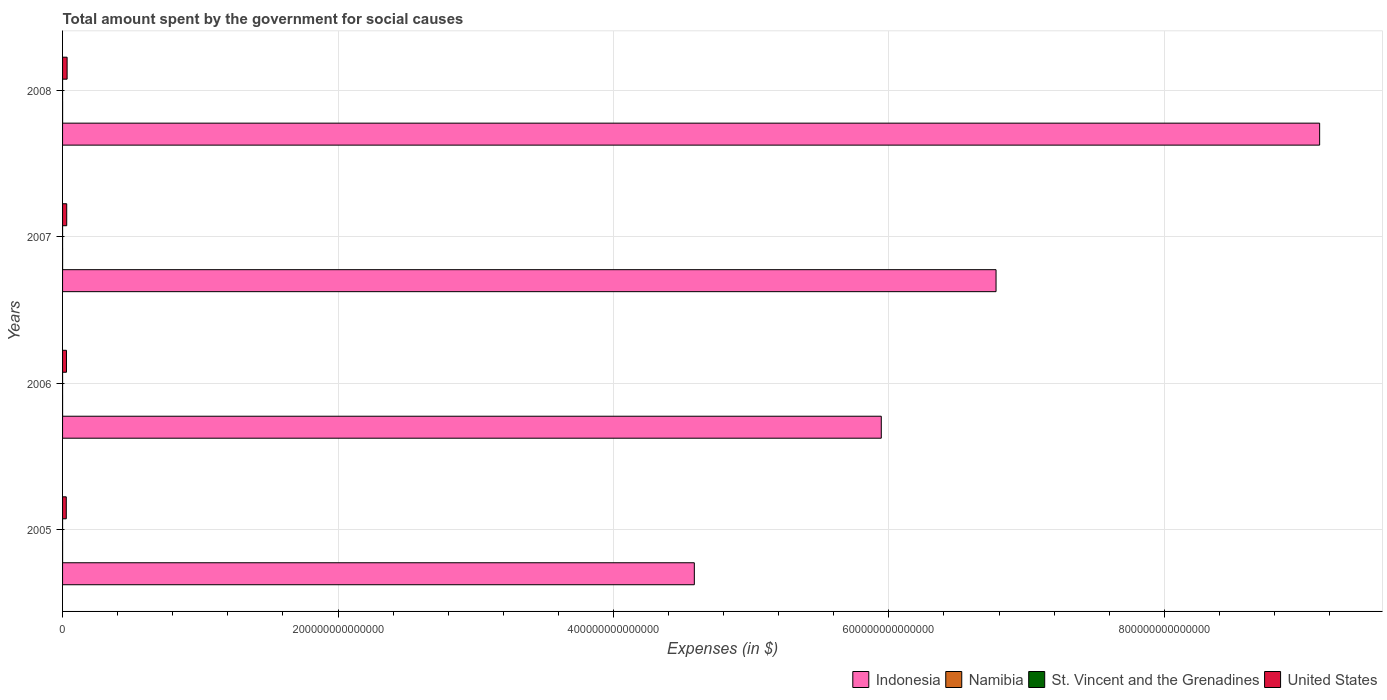How many different coloured bars are there?
Offer a very short reply. 4. How many groups of bars are there?
Make the answer very short. 4. Are the number of bars per tick equal to the number of legend labels?
Your answer should be compact. Yes. How many bars are there on the 1st tick from the top?
Your answer should be compact. 4. How many bars are there on the 4th tick from the bottom?
Provide a short and direct response. 4. In how many cases, is the number of bars for a given year not equal to the number of legend labels?
Offer a terse response. 0. What is the amount spent for social causes by the government in Namibia in 2005?
Offer a very short reply. 1.18e+1. Across all years, what is the maximum amount spent for social causes by the government in Indonesia?
Your answer should be very brief. 9.13e+14. Across all years, what is the minimum amount spent for social causes by the government in United States?
Provide a short and direct response. 2.70e+12. What is the total amount spent for social causes by the government in Namibia in the graph?
Provide a short and direct response. 5.79e+1. What is the difference between the amount spent for social causes by the government in Namibia in 2006 and that in 2007?
Your answer should be very brief. -1.83e+09. What is the difference between the amount spent for social causes by the government in United States in 2008 and the amount spent for social causes by the government in St. Vincent and the Grenadines in 2007?
Provide a short and direct response. 3.29e+12. What is the average amount spent for social causes by the government in Indonesia per year?
Offer a very short reply. 6.61e+14. In the year 2006, what is the difference between the amount spent for social causes by the government in United States and amount spent for social causes by the government in Namibia?
Offer a terse response. 2.83e+12. What is the ratio of the amount spent for social causes by the government in St. Vincent and the Grenadines in 2007 to that in 2008?
Give a very brief answer. 0.88. What is the difference between the highest and the second highest amount spent for social causes by the government in Indonesia?
Your response must be concise. 2.35e+14. What is the difference between the highest and the lowest amount spent for social causes by the government in Namibia?
Your answer should be very brief. 6.18e+09. In how many years, is the amount spent for social causes by the government in St. Vincent and the Grenadines greater than the average amount spent for social causes by the government in St. Vincent and the Grenadines taken over all years?
Your response must be concise. 2. Is the sum of the amount spent for social causes by the government in Indonesia in 2006 and 2007 greater than the maximum amount spent for social causes by the government in Namibia across all years?
Keep it short and to the point. Yes. Is it the case that in every year, the sum of the amount spent for social causes by the government in Namibia and amount spent for social causes by the government in United States is greater than the sum of amount spent for social causes by the government in Indonesia and amount spent for social causes by the government in St. Vincent and the Grenadines?
Provide a short and direct response. Yes. What does the 3rd bar from the top in 2005 represents?
Provide a short and direct response. Namibia. What does the 3rd bar from the bottom in 2007 represents?
Your response must be concise. St. Vincent and the Grenadines. How many bars are there?
Make the answer very short. 16. How many years are there in the graph?
Your response must be concise. 4. What is the difference between two consecutive major ticks on the X-axis?
Provide a short and direct response. 2.00e+14. Does the graph contain any zero values?
Keep it short and to the point. No. Does the graph contain grids?
Your answer should be compact. Yes. How are the legend labels stacked?
Your answer should be very brief. Horizontal. What is the title of the graph?
Your response must be concise. Total amount spent by the government for social causes. What is the label or title of the X-axis?
Offer a very short reply. Expenses (in $). What is the label or title of the Y-axis?
Your answer should be compact. Years. What is the Expenses (in $) in Indonesia in 2005?
Offer a terse response. 4.59e+14. What is the Expenses (in $) of Namibia in 2005?
Your answer should be very brief. 1.18e+1. What is the Expenses (in $) in St. Vincent and the Grenadines in 2005?
Your response must be concise. 3.27e+08. What is the Expenses (in $) in United States in 2005?
Ensure brevity in your answer.  2.70e+12. What is the Expenses (in $) in Indonesia in 2006?
Your answer should be compact. 5.94e+14. What is the Expenses (in $) in Namibia in 2006?
Your answer should be very brief. 1.31e+1. What is the Expenses (in $) in St. Vincent and the Grenadines in 2006?
Ensure brevity in your answer.  3.56e+08. What is the Expenses (in $) in United States in 2006?
Your answer should be very brief. 2.84e+12. What is the Expenses (in $) in Indonesia in 2007?
Offer a terse response. 6.78e+14. What is the Expenses (in $) of Namibia in 2007?
Provide a succinct answer. 1.49e+1. What is the Expenses (in $) of St. Vincent and the Grenadines in 2007?
Keep it short and to the point. 3.79e+08. What is the Expenses (in $) in United States in 2007?
Provide a succinct answer. 3.01e+12. What is the Expenses (in $) in Indonesia in 2008?
Offer a terse response. 9.13e+14. What is the Expenses (in $) in Namibia in 2008?
Offer a terse response. 1.80e+1. What is the Expenses (in $) of St. Vincent and the Grenadines in 2008?
Give a very brief answer. 4.31e+08. What is the Expenses (in $) of United States in 2008?
Keep it short and to the point. 3.30e+12. Across all years, what is the maximum Expenses (in $) of Indonesia?
Ensure brevity in your answer.  9.13e+14. Across all years, what is the maximum Expenses (in $) in Namibia?
Give a very brief answer. 1.80e+1. Across all years, what is the maximum Expenses (in $) of St. Vincent and the Grenadines?
Provide a succinct answer. 4.31e+08. Across all years, what is the maximum Expenses (in $) of United States?
Your answer should be very brief. 3.30e+12. Across all years, what is the minimum Expenses (in $) of Indonesia?
Offer a very short reply. 4.59e+14. Across all years, what is the minimum Expenses (in $) in Namibia?
Keep it short and to the point. 1.18e+1. Across all years, what is the minimum Expenses (in $) of St. Vincent and the Grenadines?
Provide a short and direct response. 3.27e+08. Across all years, what is the minimum Expenses (in $) of United States?
Provide a succinct answer. 2.70e+12. What is the total Expenses (in $) of Indonesia in the graph?
Ensure brevity in your answer.  2.64e+15. What is the total Expenses (in $) in Namibia in the graph?
Ensure brevity in your answer.  5.79e+1. What is the total Expenses (in $) of St. Vincent and the Grenadines in the graph?
Your answer should be very brief. 1.49e+09. What is the total Expenses (in $) in United States in the graph?
Make the answer very short. 1.18e+13. What is the difference between the Expenses (in $) of Indonesia in 2005 and that in 2006?
Provide a succinct answer. -1.36e+14. What is the difference between the Expenses (in $) in Namibia in 2005 and that in 2006?
Offer a terse response. -1.27e+09. What is the difference between the Expenses (in $) of St. Vincent and the Grenadines in 2005 and that in 2006?
Ensure brevity in your answer.  -2.93e+07. What is the difference between the Expenses (in $) of United States in 2005 and that in 2006?
Provide a short and direct response. -1.41e+11. What is the difference between the Expenses (in $) of Indonesia in 2005 and that in 2007?
Your response must be concise. -2.19e+14. What is the difference between the Expenses (in $) in Namibia in 2005 and that in 2007?
Keep it short and to the point. -3.11e+09. What is the difference between the Expenses (in $) of St. Vincent and the Grenadines in 2005 and that in 2007?
Your answer should be very brief. -5.17e+07. What is the difference between the Expenses (in $) of United States in 2005 and that in 2007?
Provide a succinct answer. -3.15e+11. What is the difference between the Expenses (in $) of Indonesia in 2005 and that in 2008?
Keep it short and to the point. -4.54e+14. What is the difference between the Expenses (in $) of Namibia in 2005 and that in 2008?
Offer a terse response. -6.18e+09. What is the difference between the Expenses (in $) of St. Vincent and the Grenadines in 2005 and that in 2008?
Your response must be concise. -1.04e+08. What is the difference between the Expenses (in $) of United States in 2005 and that in 2008?
Offer a very short reply. -5.97e+11. What is the difference between the Expenses (in $) in Indonesia in 2006 and that in 2007?
Your response must be concise. -8.33e+13. What is the difference between the Expenses (in $) in Namibia in 2006 and that in 2007?
Your answer should be compact. -1.83e+09. What is the difference between the Expenses (in $) in St. Vincent and the Grenadines in 2006 and that in 2007?
Provide a short and direct response. -2.24e+07. What is the difference between the Expenses (in $) of United States in 2006 and that in 2007?
Make the answer very short. -1.74e+11. What is the difference between the Expenses (in $) of Indonesia in 2006 and that in 2008?
Your response must be concise. -3.18e+14. What is the difference between the Expenses (in $) in Namibia in 2006 and that in 2008?
Offer a terse response. -4.91e+09. What is the difference between the Expenses (in $) in St. Vincent and the Grenadines in 2006 and that in 2008?
Make the answer very short. -7.44e+07. What is the difference between the Expenses (in $) in United States in 2006 and that in 2008?
Give a very brief answer. -4.56e+11. What is the difference between the Expenses (in $) of Indonesia in 2007 and that in 2008?
Ensure brevity in your answer.  -2.35e+14. What is the difference between the Expenses (in $) of Namibia in 2007 and that in 2008?
Ensure brevity in your answer.  -3.08e+09. What is the difference between the Expenses (in $) in St. Vincent and the Grenadines in 2007 and that in 2008?
Your answer should be very brief. -5.20e+07. What is the difference between the Expenses (in $) of United States in 2007 and that in 2008?
Make the answer very short. -2.81e+11. What is the difference between the Expenses (in $) of Indonesia in 2005 and the Expenses (in $) of Namibia in 2006?
Provide a succinct answer. 4.59e+14. What is the difference between the Expenses (in $) in Indonesia in 2005 and the Expenses (in $) in St. Vincent and the Grenadines in 2006?
Your response must be concise. 4.59e+14. What is the difference between the Expenses (in $) of Indonesia in 2005 and the Expenses (in $) of United States in 2006?
Keep it short and to the point. 4.56e+14. What is the difference between the Expenses (in $) in Namibia in 2005 and the Expenses (in $) in St. Vincent and the Grenadines in 2006?
Offer a very short reply. 1.15e+1. What is the difference between the Expenses (in $) of Namibia in 2005 and the Expenses (in $) of United States in 2006?
Your answer should be compact. -2.83e+12. What is the difference between the Expenses (in $) in St. Vincent and the Grenadines in 2005 and the Expenses (in $) in United States in 2006?
Keep it short and to the point. -2.84e+12. What is the difference between the Expenses (in $) in Indonesia in 2005 and the Expenses (in $) in Namibia in 2007?
Offer a terse response. 4.59e+14. What is the difference between the Expenses (in $) of Indonesia in 2005 and the Expenses (in $) of St. Vincent and the Grenadines in 2007?
Offer a very short reply. 4.59e+14. What is the difference between the Expenses (in $) in Indonesia in 2005 and the Expenses (in $) in United States in 2007?
Ensure brevity in your answer.  4.56e+14. What is the difference between the Expenses (in $) of Namibia in 2005 and the Expenses (in $) of St. Vincent and the Grenadines in 2007?
Offer a very short reply. 1.15e+1. What is the difference between the Expenses (in $) of Namibia in 2005 and the Expenses (in $) of United States in 2007?
Your answer should be compact. -3.00e+12. What is the difference between the Expenses (in $) in St. Vincent and the Grenadines in 2005 and the Expenses (in $) in United States in 2007?
Make the answer very short. -3.01e+12. What is the difference between the Expenses (in $) in Indonesia in 2005 and the Expenses (in $) in Namibia in 2008?
Provide a succinct answer. 4.59e+14. What is the difference between the Expenses (in $) of Indonesia in 2005 and the Expenses (in $) of St. Vincent and the Grenadines in 2008?
Provide a succinct answer. 4.59e+14. What is the difference between the Expenses (in $) in Indonesia in 2005 and the Expenses (in $) in United States in 2008?
Keep it short and to the point. 4.55e+14. What is the difference between the Expenses (in $) of Namibia in 2005 and the Expenses (in $) of St. Vincent and the Grenadines in 2008?
Give a very brief answer. 1.14e+1. What is the difference between the Expenses (in $) of Namibia in 2005 and the Expenses (in $) of United States in 2008?
Your response must be concise. -3.28e+12. What is the difference between the Expenses (in $) in St. Vincent and the Grenadines in 2005 and the Expenses (in $) in United States in 2008?
Give a very brief answer. -3.29e+12. What is the difference between the Expenses (in $) of Indonesia in 2006 and the Expenses (in $) of Namibia in 2007?
Give a very brief answer. 5.94e+14. What is the difference between the Expenses (in $) of Indonesia in 2006 and the Expenses (in $) of St. Vincent and the Grenadines in 2007?
Offer a terse response. 5.94e+14. What is the difference between the Expenses (in $) of Indonesia in 2006 and the Expenses (in $) of United States in 2007?
Make the answer very short. 5.91e+14. What is the difference between the Expenses (in $) of Namibia in 2006 and the Expenses (in $) of St. Vincent and the Grenadines in 2007?
Provide a succinct answer. 1.27e+1. What is the difference between the Expenses (in $) in Namibia in 2006 and the Expenses (in $) in United States in 2007?
Your answer should be compact. -3.00e+12. What is the difference between the Expenses (in $) of St. Vincent and the Grenadines in 2006 and the Expenses (in $) of United States in 2007?
Give a very brief answer. -3.01e+12. What is the difference between the Expenses (in $) of Indonesia in 2006 and the Expenses (in $) of Namibia in 2008?
Provide a short and direct response. 5.94e+14. What is the difference between the Expenses (in $) of Indonesia in 2006 and the Expenses (in $) of St. Vincent and the Grenadines in 2008?
Your answer should be very brief. 5.94e+14. What is the difference between the Expenses (in $) in Indonesia in 2006 and the Expenses (in $) in United States in 2008?
Provide a short and direct response. 5.91e+14. What is the difference between the Expenses (in $) in Namibia in 2006 and the Expenses (in $) in St. Vincent and the Grenadines in 2008?
Your response must be concise. 1.27e+1. What is the difference between the Expenses (in $) in Namibia in 2006 and the Expenses (in $) in United States in 2008?
Your answer should be compact. -3.28e+12. What is the difference between the Expenses (in $) of St. Vincent and the Grenadines in 2006 and the Expenses (in $) of United States in 2008?
Your answer should be compact. -3.29e+12. What is the difference between the Expenses (in $) of Indonesia in 2007 and the Expenses (in $) of Namibia in 2008?
Offer a very short reply. 6.78e+14. What is the difference between the Expenses (in $) of Indonesia in 2007 and the Expenses (in $) of St. Vincent and the Grenadines in 2008?
Keep it short and to the point. 6.78e+14. What is the difference between the Expenses (in $) of Indonesia in 2007 and the Expenses (in $) of United States in 2008?
Keep it short and to the point. 6.75e+14. What is the difference between the Expenses (in $) of Namibia in 2007 and the Expenses (in $) of St. Vincent and the Grenadines in 2008?
Provide a short and direct response. 1.45e+1. What is the difference between the Expenses (in $) in Namibia in 2007 and the Expenses (in $) in United States in 2008?
Ensure brevity in your answer.  -3.28e+12. What is the difference between the Expenses (in $) of St. Vincent and the Grenadines in 2007 and the Expenses (in $) of United States in 2008?
Your response must be concise. -3.29e+12. What is the average Expenses (in $) in Indonesia per year?
Your answer should be very brief. 6.61e+14. What is the average Expenses (in $) of Namibia per year?
Keep it short and to the point. 1.45e+1. What is the average Expenses (in $) of St. Vincent and the Grenadines per year?
Offer a very short reply. 3.73e+08. What is the average Expenses (in $) of United States per year?
Offer a terse response. 2.96e+12. In the year 2005, what is the difference between the Expenses (in $) of Indonesia and Expenses (in $) of Namibia?
Your answer should be very brief. 4.59e+14. In the year 2005, what is the difference between the Expenses (in $) in Indonesia and Expenses (in $) in St. Vincent and the Grenadines?
Make the answer very short. 4.59e+14. In the year 2005, what is the difference between the Expenses (in $) of Indonesia and Expenses (in $) of United States?
Offer a very short reply. 4.56e+14. In the year 2005, what is the difference between the Expenses (in $) in Namibia and Expenses (in $) in St. Vincent and the Grenadines?
Ensure brevity in your answer.  1.15e+1. In the year 2005, what is the difference between the Expenses (in $) in Namibia and Expenses (in $) in United States?
Your answer should be very brief. -2.69e+12. In the year 2005, what is the difference between the Expenses (in $) in St. Vincent and the Grenadines and Expenses (in $) in United States?
Your answer should be compact. -2.70e+12. In the year 2006, what is the difference between the Expenses (in $) of Indonesia and Expenses (in $) of Namibia?
Offer a very short reply. 5.94e+14. In the year 2006, what is the difference between the Expenses (in $) of Indonesia and Expenses (in $) of St. Vincent and the Grenadines?
Provide a succinct answer. 5.94e+14. In the year 2006, what is the difference between the Expenses (in $) in Indonesia and Expenses (in $) in United States?
Your response must be concise. 5.92e+14. In the year 2006, what is the difference between the Expenses (in $) in Namibia and Expenses (in $) in St. Vincent and the Grenadines?
Make the answer very short. 1.28e+1. In the year 2006, what is the difference between the Expenses (in $) in Namibia and Expenses (in $) in United States?
Ensure brevity in your answer.  -2.83e+12. In the year 2006, what is the difference between the Expenses (in $) of St. Vincent and the Grenadines and Expenses (in $) of United States?
Provide a short and direct response. -2.84e+12. In the year 2007, what is the difference between the Expenses (in $) of Indonesia and Expenses (in $) of Namibia?
Ensure brevity in your answer.  6.78e+14. In the year 2007, what is the difference between the Expenses (in $) of Indonesia and Expenses (in $) of St. Vincent and the Grenadines?
Offer a terse response. 6.78e+14. In the year 2007, what is the difference between the Expenses (in $) in Indonesia and Expenses (in $) in United States?
Ensure brevity in your answer.  6.75e+14. In the year 2007, what is the difference between the Expenses (in $) in Namibia and Expenses (in $) in St. Vincent and the Grenadines?
Your answer should be very brief. 1.46e+1. In the year 2007, what is the difference between the Expenses (in $) in Namibia and Expenses (in $) in United States?
Your answer should be compact. -3.00e+12. In the year 2007, what is the difference between the Expenses (in $) of St. Vincent and the Grenadines and Expenses (in $) of United States?
Your answer should be compact. -3.01e+12. In the year 2008, what is the difference between the Expenses (in $) in Indonesia and Expenses (in $) in Namibia?
Give a very brief answer. 9.13e+14. In the year 2008, what is the difference between the Expenses (in $) of Indonesia and Expenses (in $) of St. Vincent and the Grenadines?
Your response must be concise. 9.13e+14. In the year 2008, what is the difference between the Expenses (in $) of Indonesia and Expenses (in $) of United States?
Provide a short and direct response. 9.09e+14. In the year 2008, what is the difference between the Expenses (in $) of Namibia and Expenses (in $) of St. Vincent and the Grenadines?
Provide a succinct answer. 1.76e+1. In the year 2008, what is the difference between the Expenses (in $) in Namibia and Expenses (in $) in United States?
Provide a short and direct response. -3.28e+12. In the year 2008, what is the difference between the Expenses (in $) in St. Vincent and the Grenadines and Expenses (in $) in United States?
Your answer should be very brief. -3.29e+12. What is the ratio of the Expenses (in $) of Indonesia in 2005 to that in 2006?
Provide a short and direct response. 0.77. What is the ratio of the Expenses (in $) of Namibia in 2005 to that in 2006?
Ensure brevity in your answer.  0.9. What is the ratio of the Expenses (in $) of St. Vincent and the Grenadines in 2005 to that in 2006?
Offer a terse response. 0.92. What is the ratio of the Expenses (in $) of United States in 2005 to that in 2006?
Provide a succinct answer. 0.95. What is the ratio of the Expenses (in $) in Indonesia in 2005 to that in 2007?
Your answer should be very brief. 0.68. What is the ratio of the Expenses (in $) in Namibia in 2005 to that in 2007?
Keep it short and to the point. 0.79. What is the ratio of the Expenses (in $) in St. Vincent and the Grenadines in 2005 to that in 2007?
Ensure brevity in your answer.  0.86. What is the ratio of the Expenses (in $) in United States in 2005 to that in 2007?
Offer a terse response. 0.9. What is the ratio of the Expenses (in $) in Indonesia in 2005 to that in 2008?
Your answer should be compact. 0.5. What is the ratio of the Expenses (in $) of Namibia in 2005 to that in 2008?
Give a very brief answer. 0.66. What is the ratio of the Expenses (in $) in St. Vincent and the Grenadines in 2005 to that in 2008?
Your answer should be compact. 0.76. What is the ratio of the Expenses (in $) of United States in 2005 to that in 2008?
Give a very brief answer. 0.82. What is the ratio of the Expenses (in $) of Indonesia in 2006 to that in 2007?
Offer a terse response. 0.88. What is the ratio of the Expenses (in $) of Namibia in 2006 to that in 2007?
Keep it short and to the point. 0.88. What is the ratio of the Expenses (in $) in St. Vincent and the Grenadines in 2006 to that in 2007?
Give a very brief answer. 0.94. What is the ratio of the Expenses (in $) in United States in 2006 to that in 2007?
Offer a very short reply. 0.94. What is the ratio of the Expenses (in $) of Indonesia in 2006 to that in 2008?
Your response must be concise. 0.65. What is the ratio of the Expenses (in $) of Namibia in 2006 to that in 2008?
Make the answer very short. 0.73. What is the ratio of the Expenses (in $) of St. Vincent and the Grenadines in 2006 to that in 2008?
Make the answer very short. 0.83. What is the ratio of the Expenses (in $) of United States in 2006 to that in 2008?
Keep it short and to the point. 0.86. What is the ratio of the Expenses (in $) of Indonesia in 2007 to that in 2008?
Provide a succinct answer. 0.74. What is the ratio of the Expenses (in $) in Namibia in 2007 to that in 2008?
Provide a succinct answer. 0.83. What is the ratio of the Expenses (in $) in St. Vincent and the Grenadines in 2007 to that in 2008?
Provide a short and direct response. 0.88. What is the ratio of the Expenses (in $) of United States in 2007 to that in 2008?
Your response must be concise. 0.91. What is the difference between the highest and the second highest Expenses (in $) of Indonesia?
Offer a very short reply. 2.35e+14. What is the difference between the highest and the second highest Expenses (in $) of Namibia?
Offer a terse response. 3.08e+09. What is the difference between the highest and the second highest Expenses (in $) of St. Vincent and the Grenadines?
Offer a terse response. 5.20e+07. What is the difference between the highest and the second highest Expenses (in $) in United States?
Ensure brevity in your answer.  2.81e+11. What is the difference between the highest and the lowest Expenses (in $) of Indonesia?
Make the answer very short. 4.54e+14. What is the difference between the highest and the lowest Expenses (in $) in Namibia?
Make the answer very short. 6.18e+09. What is the difference between the highest and the lowest Expenses (in $) in St. Vincent and the Grenadines?
Your answer should be very brief. 1.04e+08. What is the difference between the highest and the lowest Expenses (in $) in United States?
Offer a terse response. 5.97e+11. 